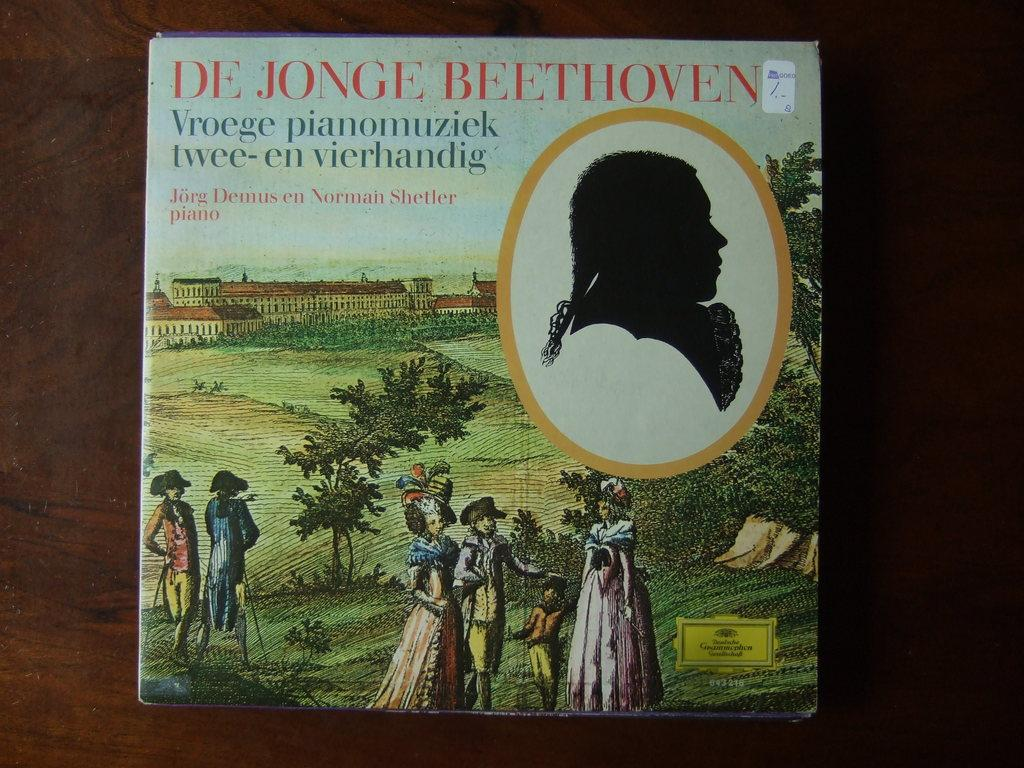<image>
Create a compact narrative representing the image presented. A book about Beethoven features someone's silhouette on the cover. 